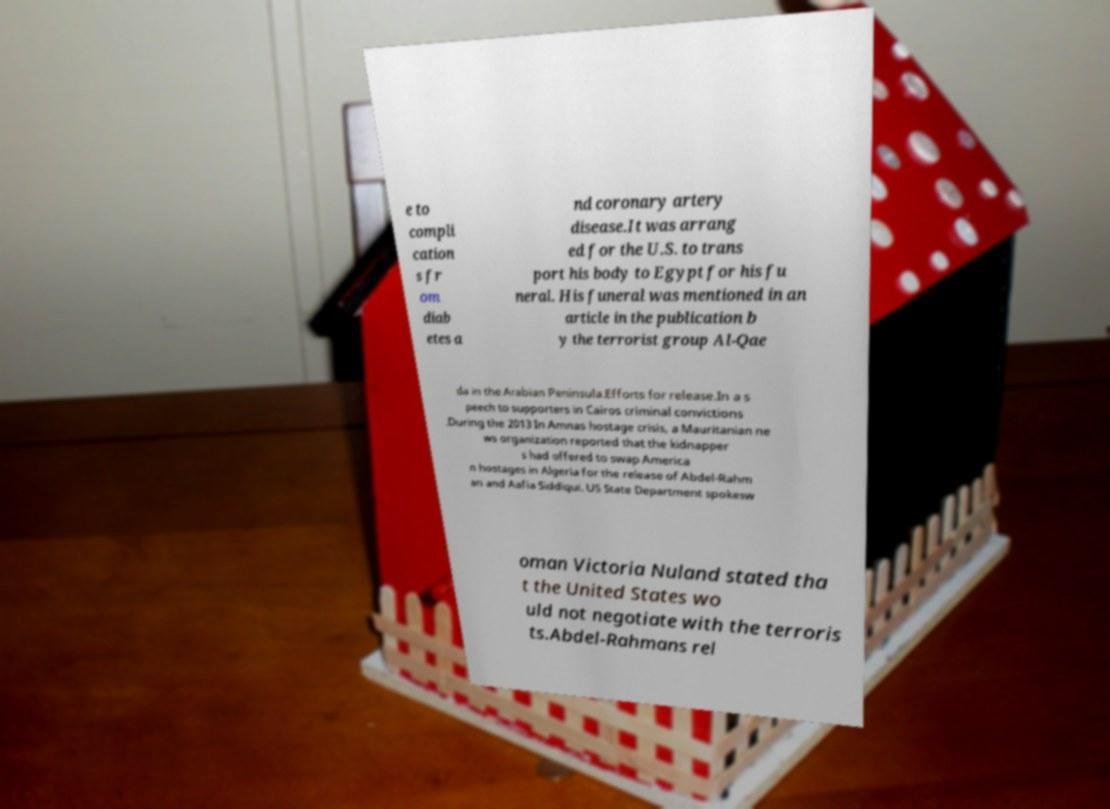Can you accurately transcribe the text from the provided image for me? e to compli cation s fr om diab etes a nd coronary artery disease.It was arrang ed for the U.S. to trans port his body to Egypt for his fu neral. His funeral was mentioned in an article in the publication b y the terrorist group Al-Qae da in the Arabian Peninsula.Efforts for release.In a s peech to supporters in Cairos criminal convictions .During the 2013 In Amnas hostage crisis, a Mauritanian ne ws organization reported that the kidnapper s had offered to swap America n hostages in Algeria for the release of Abdel-Rahm an and Aafia Siddiqui. US State Department spokesw oman Victoria Nuland stated tha t the United States wo uld not negotiate with the terroris ts.Abdel-Rahmans rel 